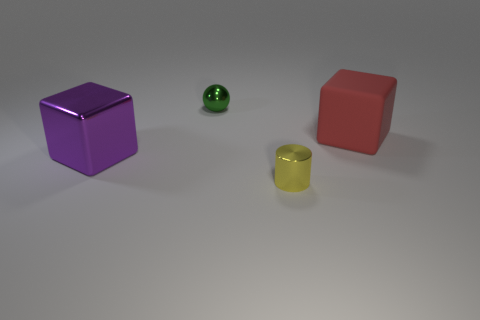Add 1 metal spheres. How many objects exist? 5 Subtract all spheres. How many objects are left? 3 Subtract all small shiny things. Subtract all small spheres. How many objects are left? 1 Add 4 large purple metallic cubes. How many large purple metallic cubes are left? 5 Add 1 small cyan shiny things. How many small cyan shiny things exist? 1 Subtract 1 purple blocks. How many objects are left? 3 